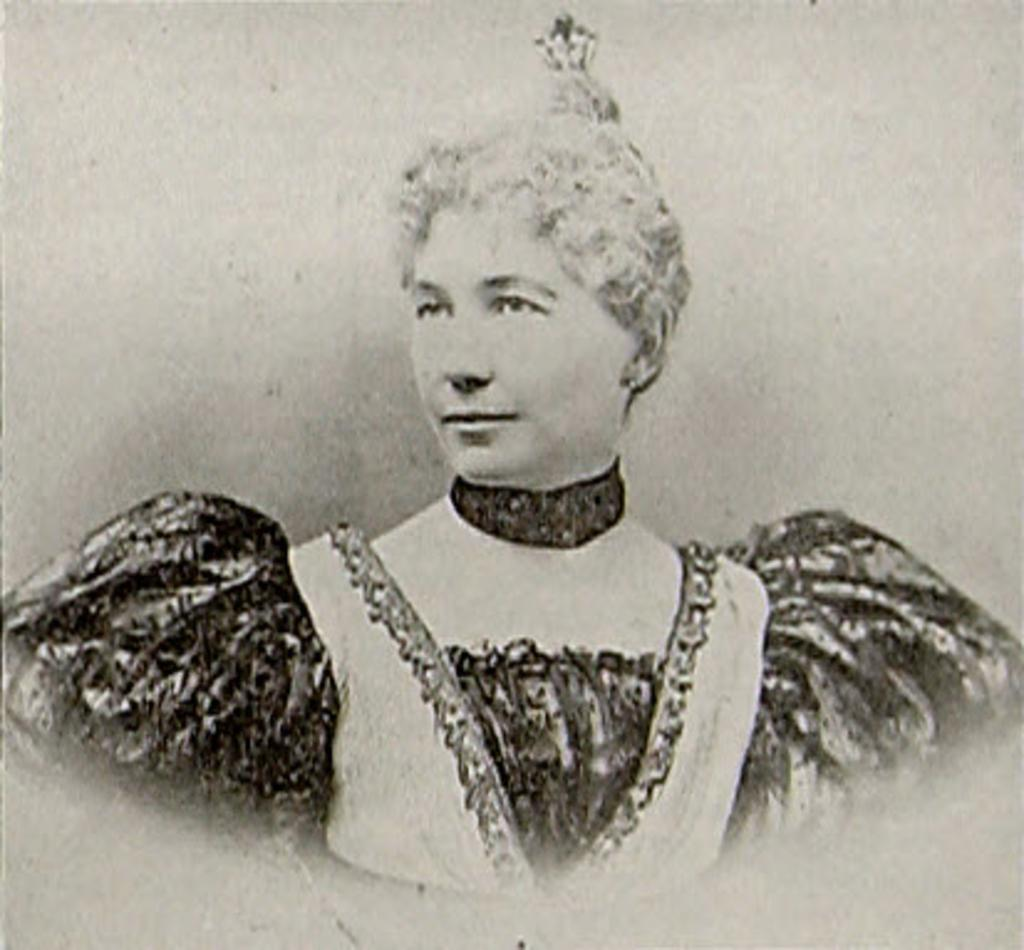What is the color scheme of the picture? The picture is black and white. Can you describe the age of the picture? The picture is old. What is the main subject of the picture? There is a woman in the picture. How many clocks are visible in the picture? There are no clocks visible in the picture. Is the woman in the picture standing in quicksand? There is no indication of quicksand in the picture, and the woman's position does not suggest she is in quicksand. 